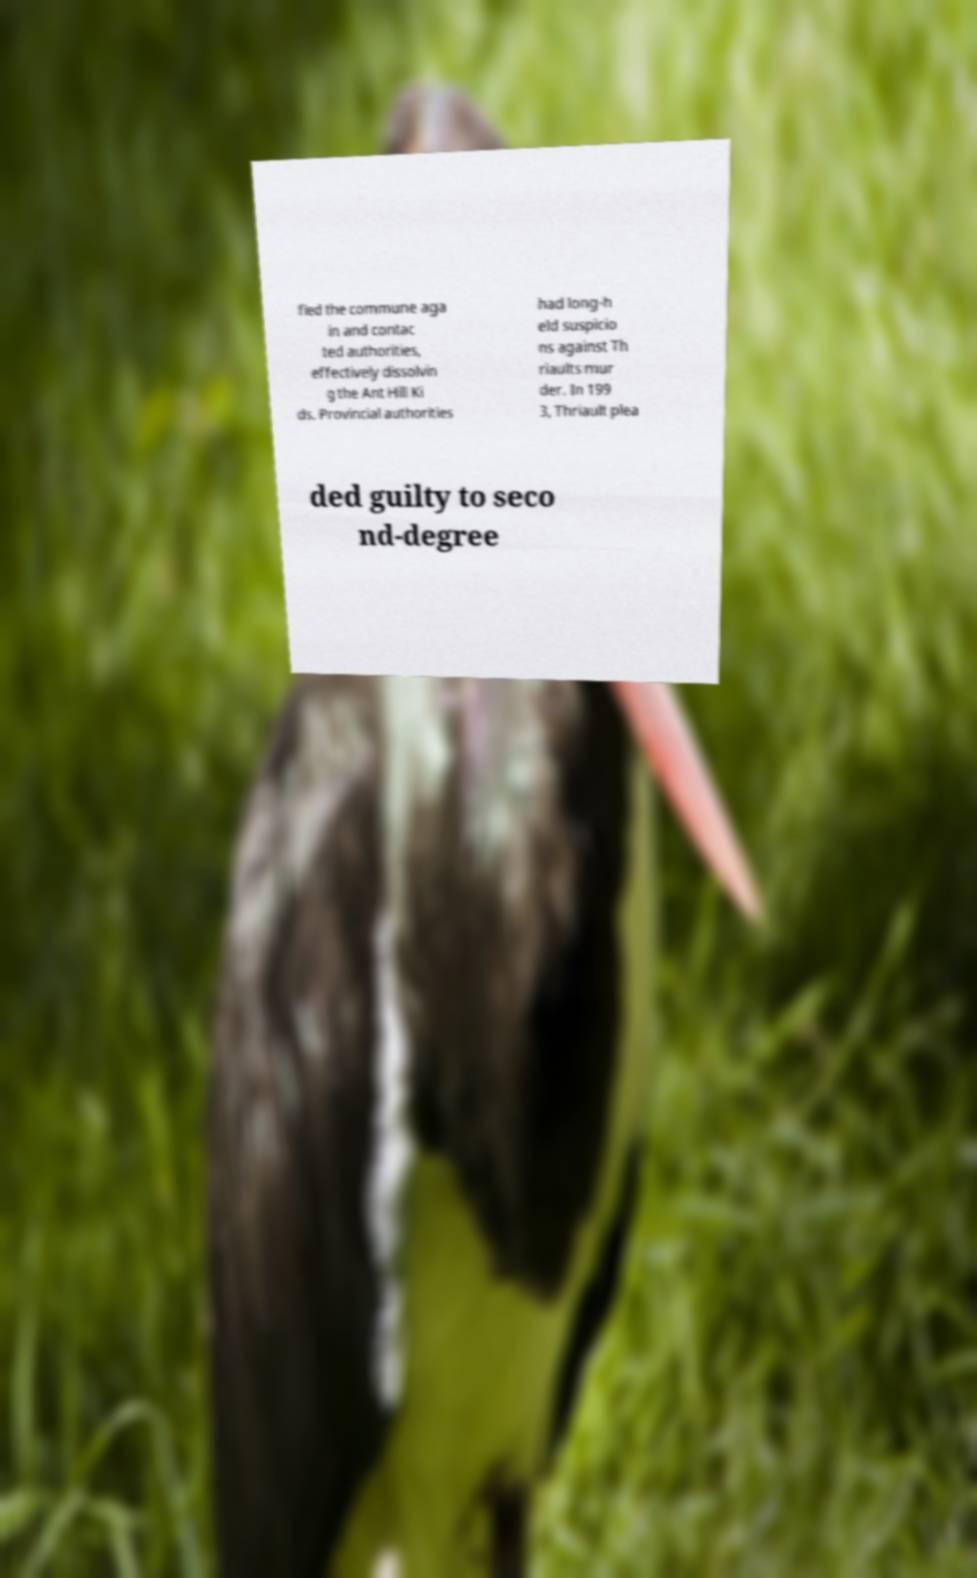Can you read and provide the text displayed in the image?This photo seems to have some interesting text. Can you extract and type it out for me? fled the commune aga in and contac ted authorities, effectively dissolvin g the Ant Hill Ki ds. Provincial authorities had long-h eld suspicio ns against Th riaults mur der. In 199 3, Thriault plea ded guilty to seco nd-degree 